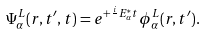<formula> <loc_0><loc_0><loc_500><loc_500>\Psi ^ { L } _ { \alpha } ( r , t ^ { \prime } , t ) = e ^ { + \frac { i } { } E ^ { * } _ { \alpha } t } \phi ^ { L } _ { \alpha } ( r , t ^ { \prime } ) .</formula> 